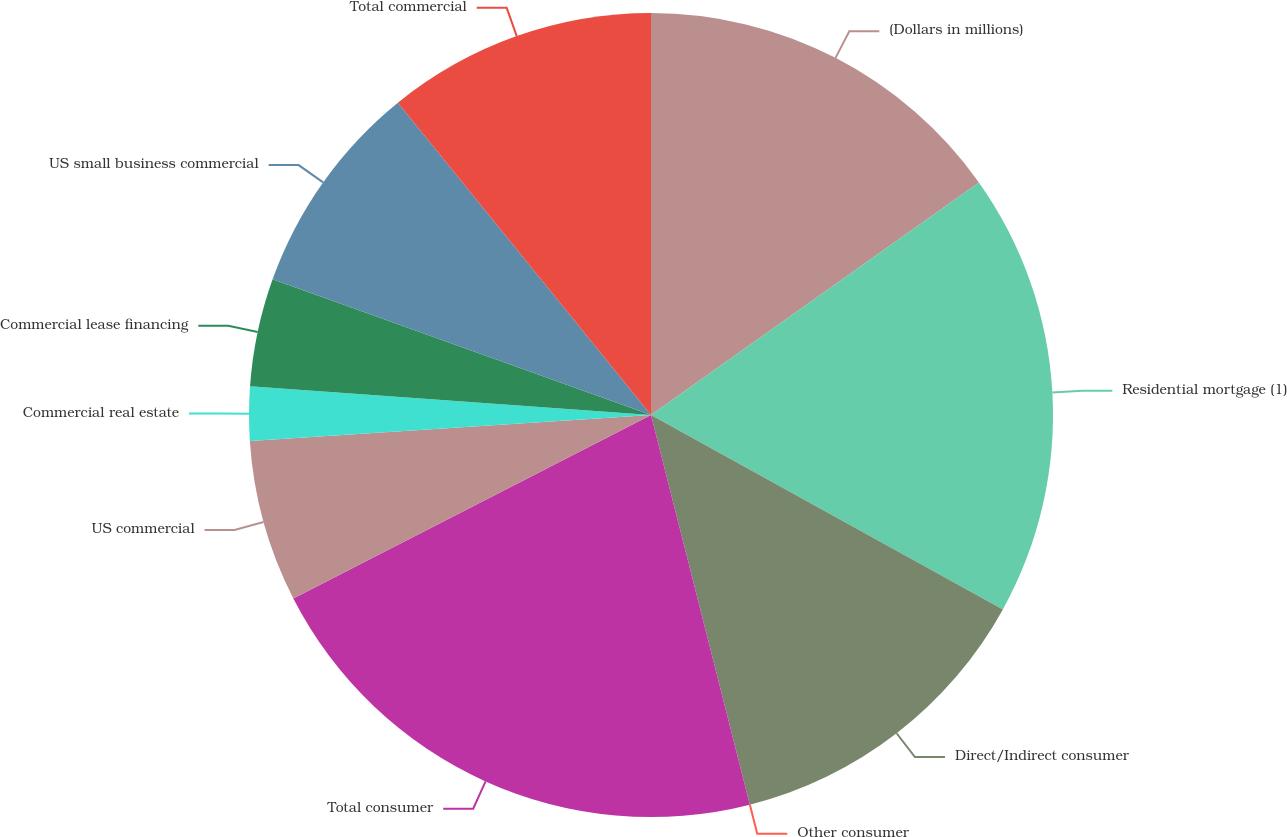Convert chart. <chart><loc_0><loc_0><loc_500><loc_500><pie_chart><fcel>(Dollars in millions)<fcel>Residential mortgage (1)<fcel>Direct/Indirect consumer<fcel>Other consumer<fcel>Total consumer<fcel>US commercial<fcel>Commercial real estate<fcel>Commercial lease financing<fcel>US small business commercial<fcel>Total commercial<nl><fcel>15.18%<fcel>17.85%<fcel>13.01%<fcel>0.0%<fcel>21.41%<fcel>6.51%<fcel>2.17%<fcel>4.34%<fcel>8.68%<fcel>10.84%<nl></chart> 